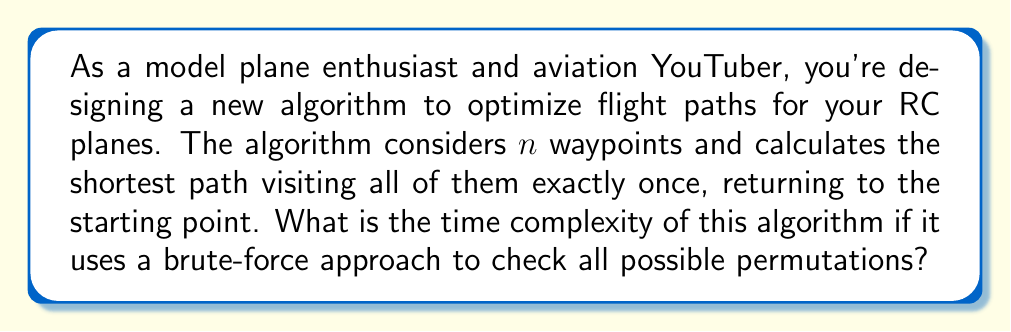Solve this math problem. Let's break this down step-by-step:

1) First, we need to understand what the algorithm is doing. It's essentially solving the Traveling Salesman Problem (TSP) for $n$ waypoints using a brute-force approach.

2) In a brute-force approach for TSP, we generate all possible permutations of the waypoints and calculate the total distance for each permutation.

3) The number of permutations for $n$ distinct waypoints is $n!$ (n factorial).

4) For each permutation, we need to calculate the total distance. This involves summing up the distances between $n$ pairs of points (including the return to the start).

5) Calculating the distance between two points is typically considered a constant time operation, $O(1)$.

6) Therefore, for each permutation, we perform $n$ distance calculations and $n-1$ additions, which is $O(n)$.

7) We do this $O(n)$ operation for each of the $n!$ permutations.

8) Thus, the total time complexity is the product of the number of permutations and the time to process each permutation:

   $$O(n! \cdot n) = O(n \cdot n!)$$

This is the final time complexity of the algorithm.
Answer: $O(n \cdot n!)$ 